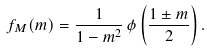<formula> <loc_0><loc_0><loc_500><loc_500>f _ { M } ( m ) = \frac { 1 } { 1 - m ^ { 2 } } \, \phi \left ( \frac { 1 \pm m } { 2 } \right ) .</formula> 